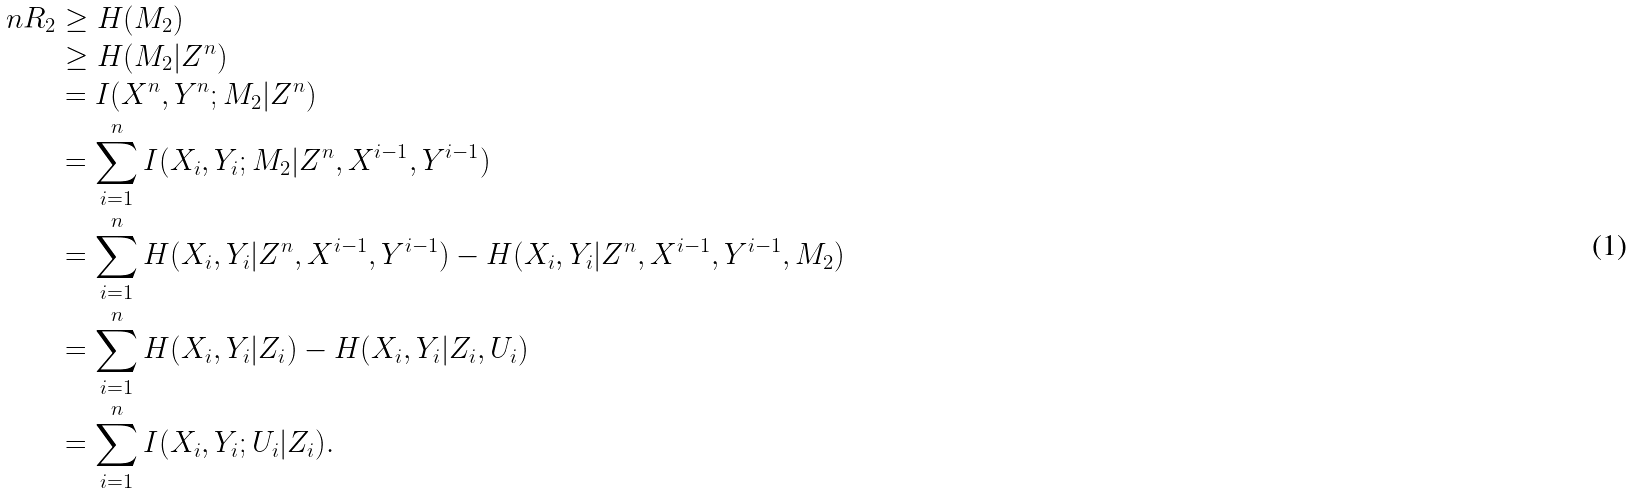<formula> <loc_0><loc_0><loc_500><loc_500>n R _ { 2 } & \geq H ( M _ { 2 } ) \\ & \geq H ( M _ { 2 } | Z ^ { n } ) \\ & = I ( X ^ { n } , Y ^ { n } ; M _ { 2 } | Z ^ { n } ) \\ & = \sum _ { i = 1 } ^ { n } I ( X _ { i } , Y _ { i } ; M _ { 2 } | Z ^ { n } , X ^ { i - 1 } , Y ^ { i - 1 } ) \\ & = \sum _ { i = 1 } ^ { n } H ( X _ { i } , Y _ { i } | Z ^ { n } , X ^ { i - 1 } , Y ^ { i - 1 } ) - H ( X _ { i } , Y _ { i } | Z ^ { n } , X ^ { i - 1 } , Y ^ { i - 1 } , M _ { 2 } ) \\ & = \sum _ { i = 1 } ^ { n } H ( X _ { i } , Y _ { i } | Z _ { i } ) - H ( X _ { i } , Y _ { i } | Z _ { i } , U _ { i } ) \\ & = \sum _ { i = 1 } ^ { n } I ( X _ { i } , Y _ { i } ; U _ { i } | Z _ { i } ) .</formula> 